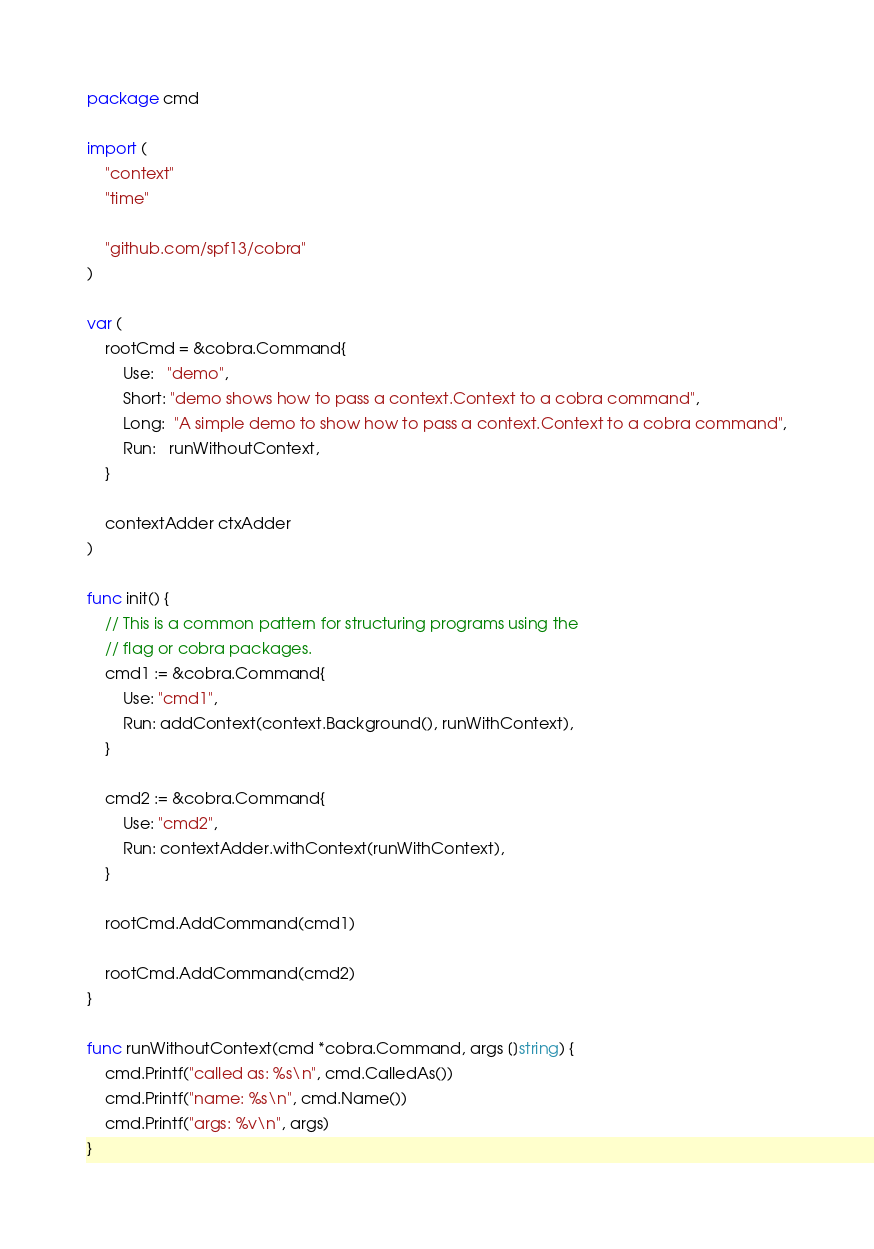Convert code to text. <code><loc_0><loc_0><loc_500><loc_500><_Go_>package cmd

import (
	"context"
	"time"

	"github.com/spf13/cobra"
)

var (
	rootCmd = &cobra.Command{
		Use:   "demo",
		Short: "demo shows how to pass a context.Context to a cobra command",
		Long:  "A simple demo to show how to pass a context.Context to a cobra command",
		Run:   runWithoutContext,
	}

	contextAdder ctxAdder
)

func init() {
	// This is a common pattern for structuring programs using the
	// flag or cobra packages.
	cmd1 := &cobra.Command{
		Use: "cmd1",
		Run: addContext(context.Background(), runWithContext),
	}

	cmd2 := &cobra.Command{
		Use: "cmd2",
		Run: contextAdder.withContext(runWithContext),
	}

	rootCmd.AddCommand(cmd1)

	rootCmd.AddCommand(cmd2)
}

func runWithoutContext(cmd *cobra.Command, args []string) {
	cmd.Printf("called as: %s\n", cmd.CalledAs())
	cmd.Printf("name: %s\n", cmd.Name())
	cmd.Printf("args: %v\n", args)
}
</code> 